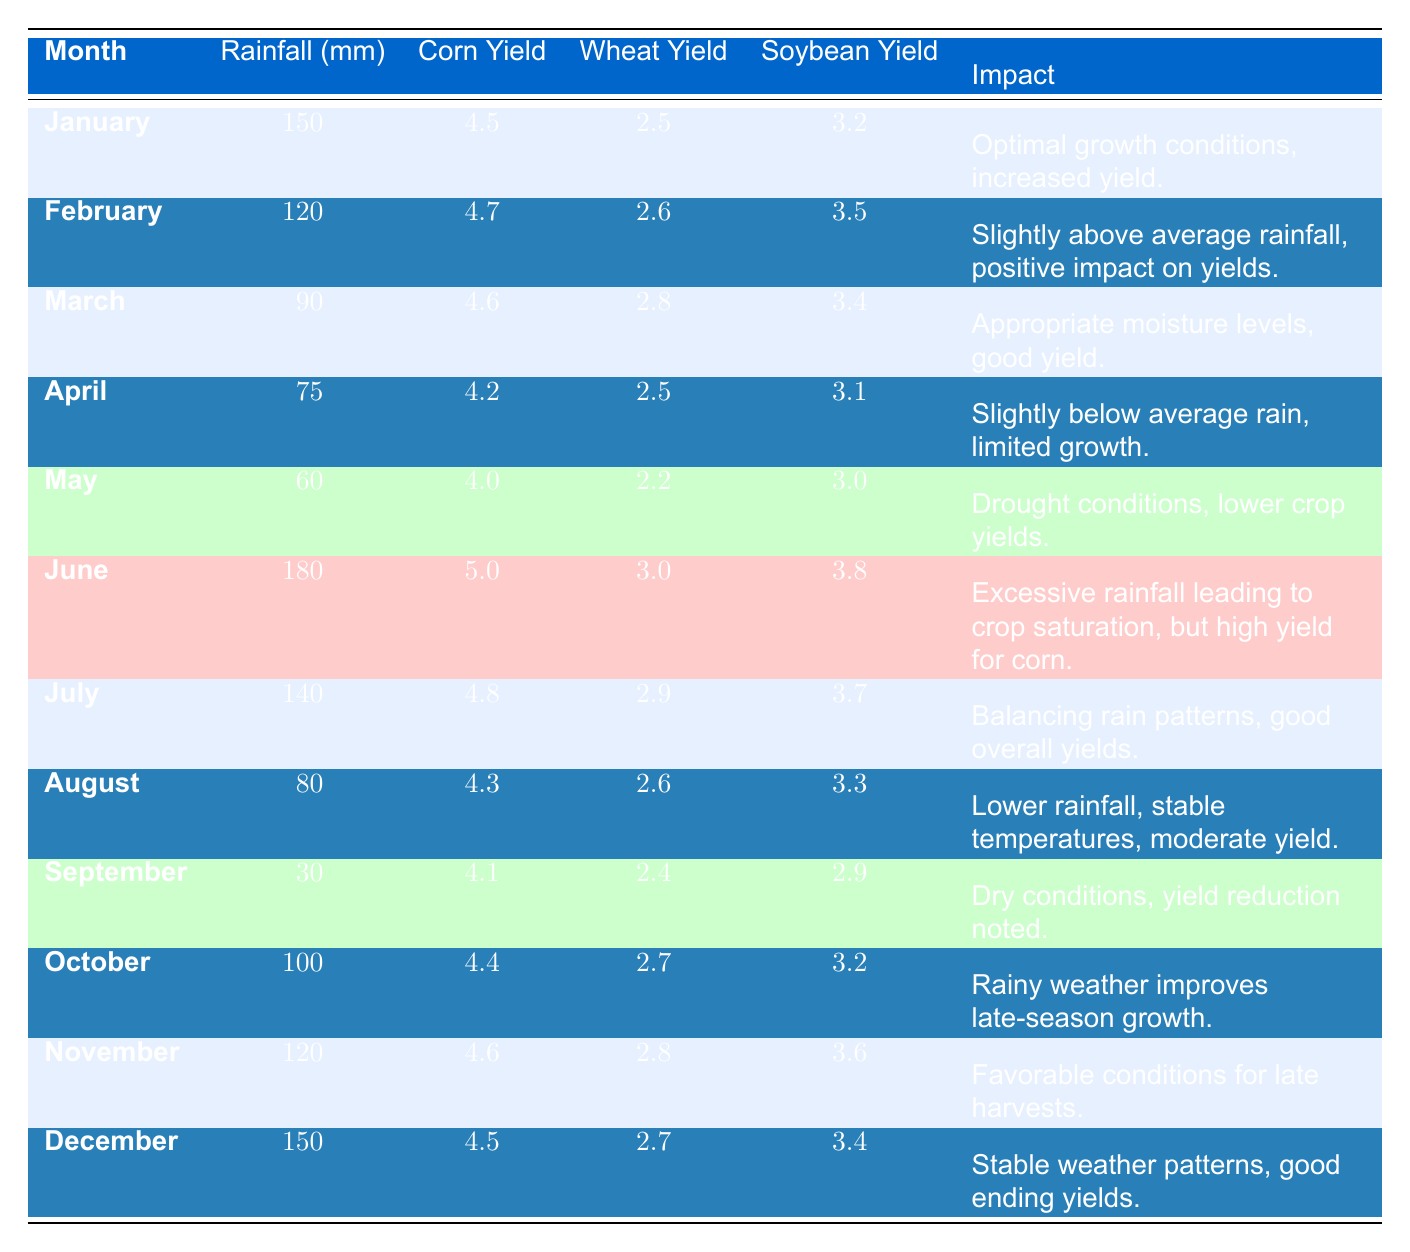What was the highest corn yield recorded in the table? By reviewing the corn yield values for each month, the highest yield is found in June with a value of 5.0 tons per hectare.
Answer: 5.0 Which month had the least amount of rainfall? The table shows that September had the least amount of rainfall with only 30 mm.
Answer: 30 mm What is the average soybean yield across all months? To calculate the average soy yield, sum all the soybean yields (3.2 + 3.5 + 3.4 + 3.1 + 3.0 + 3.8 + 3.7 + 3.3 + 2.9 + 3.2 + 3.6 + 3.4 = 39.8) and divide by the number of months (12). So, the average is 39.8 / 12 = 3.32 tons per hectare.
Answer: 3.32 Did the rainfall in June positively affect the corn yield? The rainfall in June was 180 mm, which is excessive; however, it also led to the highest corn yield of the season at 5.0 tons per hectare, indicating a positive impact despite the saturation.
Answer: Yes What was the change in corn yield from April to May? The corn yield in April is 4.2 tons per hectare and decreased to 4.0 tons in May. The change is 4.0 - 4.2 = -0.2 tons per hectare, showing a decrease.
Answer: -0.2 Which month had the optimal growth conditions for crops? January showed optimal growth conditions with 150 mm of rainfall and stated increased yields across all crops.
Answer: January What was the average rainfall from January to June? The total rainfall from January (150 mm), February (120 mm), March (90 mm), April (75 mm), May (60 mm), and June (180 mm) is 675 mm, and dividing by 6 gives an average of 675 / 6 = 112.5 mm.
Answer: 112.5 mm Is there a month with a yield reduction for corn compared to the previous month? Yes, comparing the yields, corn yield decreased from April (4.2 tons) to May (4.0 tons).
Answer: Yes What impact did September's dry conditions have on soybean yield? The soybean yield in September was noted as 2.9 tons per hectare, which is lower than previous months, likely due to dry conditions affecting growth.
Answer: Negative impact Which month shows a significant improvement in late-season crop yields? October showed rainy weather which improved late-season growth with an uptick in yield for all crops, particularly effective for corn.
Answer: October 